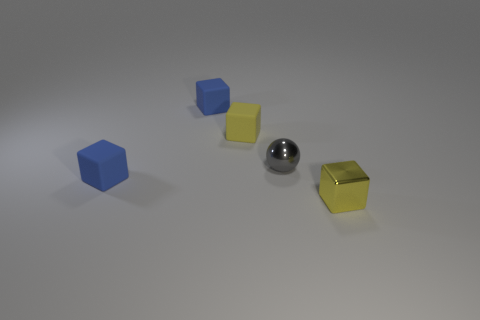There is a yellow object to the left of the yellow thing in front of the yellow cube that is to the left of the small yellow metal cube; what size is it?
Provide a succinct answer. Small. Do the tiny blue object in front of the gray metal object and the shiny object behind the small shiny block have the same shape?
Your answer should be compact. No. How many other objects are there of the same color as the small metal cube?
Keep it short and to the point. 1. Is the size of the matte object that is in front of the shiny ball the same as the yellow rubber object?
Ensure brevity in your answer.  Yes. Do the small blue object that is in front of the gray metallic thing and the yellow cube that is to the left of the tiny yellow shiny thing have the same material?
Your answer should be compact. Yes. Are there any blue blocks of the same size as the gray shiny ball?
Your response must be concise. Yes. What shape is the blue object in front of the tiny blue cube that is behind the blue thing that is in front of the small yellow rubber block?
Offer a terse response. Cube. Are there more tiny spheres that are to the left of the tiny yellow matte block than balls?
Offer a very short reply. No. Is there a small blue matte object that has the same shape as the yellow metal thing?
Your response must be concise. Yes. Is the gray sphere made of the same material as the yellow cube that is on the left side of the yellow shiny cube?
Provide a succinct answer. No. 